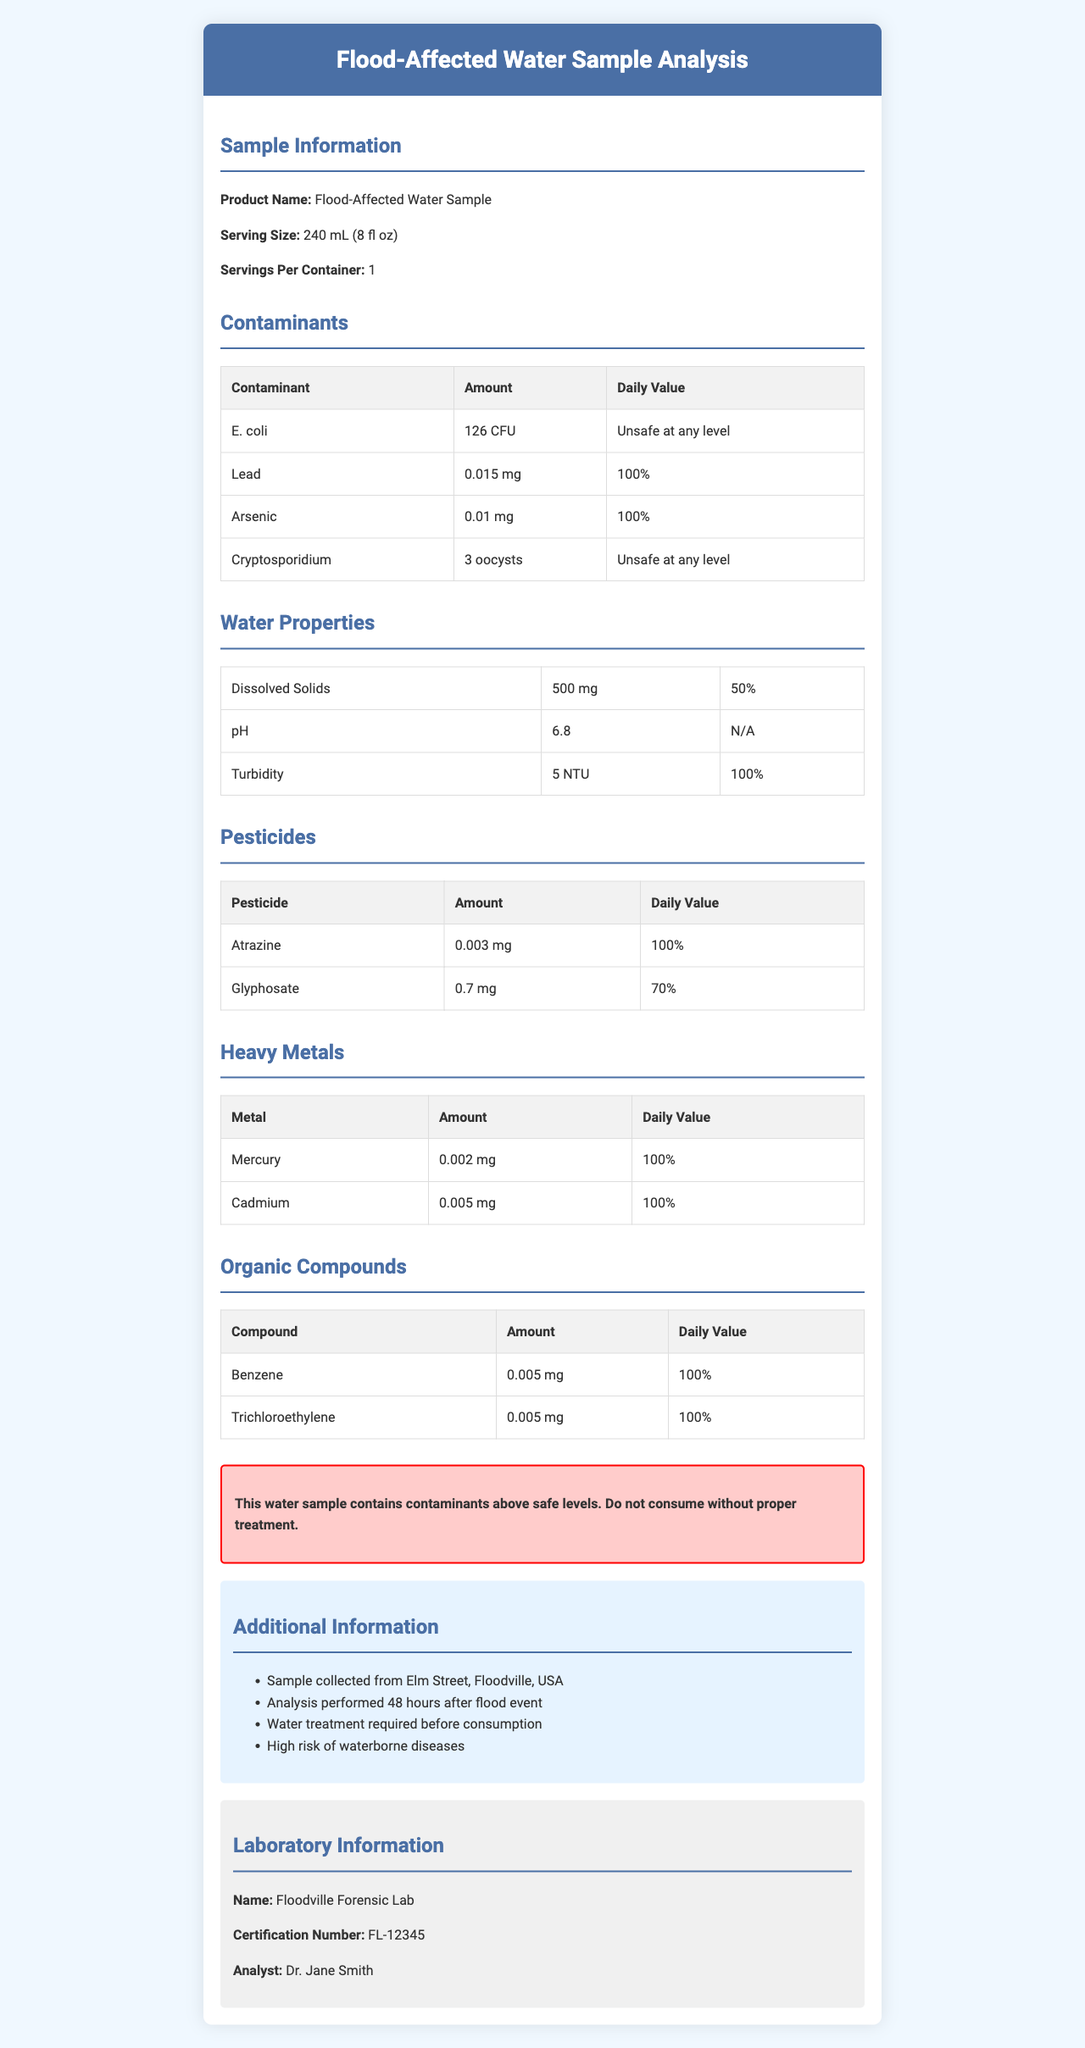what is the serving size? The serving size is specified in the "Sample Information" section of the document.
Answer: 240 mL (8 fl oz) What amount of E. coli is present in the water sample? The amount of E. coli is given in the "Contaminants" table, under the "Amount" column.
Answer: 126 CFU How does the turbidity level compare to the daily recommended value? The daily value for turbidity is specified as 100% in the "Water Properties" section.
Answer: 100% What is the pH value of the water sample? The pH value is provided in the "Water Properties" section.
Answer: 6.8 Which contaminants are listed as unsafe at any level? The "Contaminants" table mentions that both E. coli and Cryptosporidium are "Unsafe at any level."
Answer: E. coli and Cryptosporidium What is the amount of lead in the water sample? The amount of lead is provided in the "Contaminants" table under the "Amount" column.
Answer: 0.015 mg Which of the following is listed under heavy metals in the document? A. Benzene B. Glyphosate C. Cadmium D. Atrazine The "Heavy Metals" section includes Cadmium as one of the metals.
Answer: C. Cadmium What is the daily value percentage for dissolved solids? A. 50% B. 70% C. 80% D. 100% The daily value for dissolved solids is mentioned as 50% in the "Water Properties" section.
Answer: A. 50% Does the document reveal the analyst's name who performed the water analysis? The "Laboratory Information" section lists Dr. Jane Smith as the analyst.
Answer: Yes Summarize the main findings of the water sample analysis. The document details that the water is contaminated with harmful substances, making it unsafe for consumption. The analysis was done by Dr. Jane Smith at Floodville Forensic Lab.
Answer: The water sample contains several contaminants at unsafe levels, including E. coli and Cryptosporidium. Lead, arsenic, and several other harmful substances are present at concerning levels. It is not safe for consumption without treatment. The analysis was conducted at Floodville Forensic Lab by Dr. Jane Smith. When was the water sample collected relative to the flood event? The "Additional Information" section states that the sample was collected 48 hours after the flood event.
Answer: 48 hours after the flood event What treatment is required for the water sample before consumption? The "Additional Information" section cites that water treatment is necessary before consumption.
Answer: Water treatment is required before consumption Can we determine the specific techniques used for the water analysis from this document? The document does not provide details about the specific techniques used for the water analysis.
Answer: Not enough information 